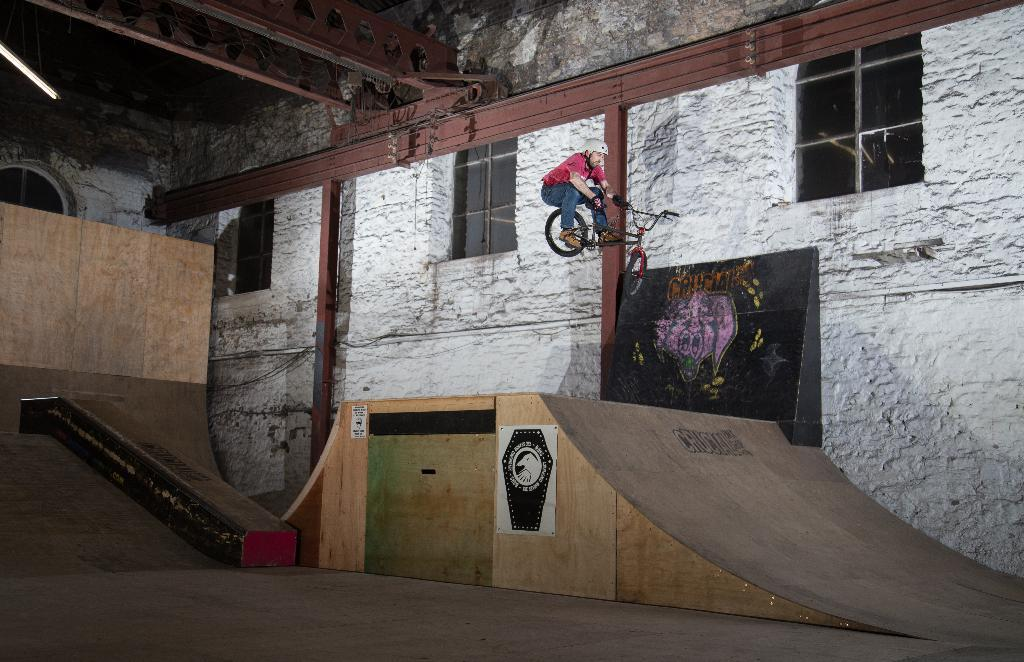What is the man doing in the image? The man is on a bicycle in the image. What is the man's position in relation to the ground? The man appears to be in the air in the image. What can be seen in the background of the image? There is a slope and a white-colored wall in the image. What architectural features are visible in the image? There are windows visible in the image. Can you see any rivers in the image? There is no river present in the image. What type of flesh can be seen on the man's bicycle? There is no flesh visible on the man's bicycle in the image. 